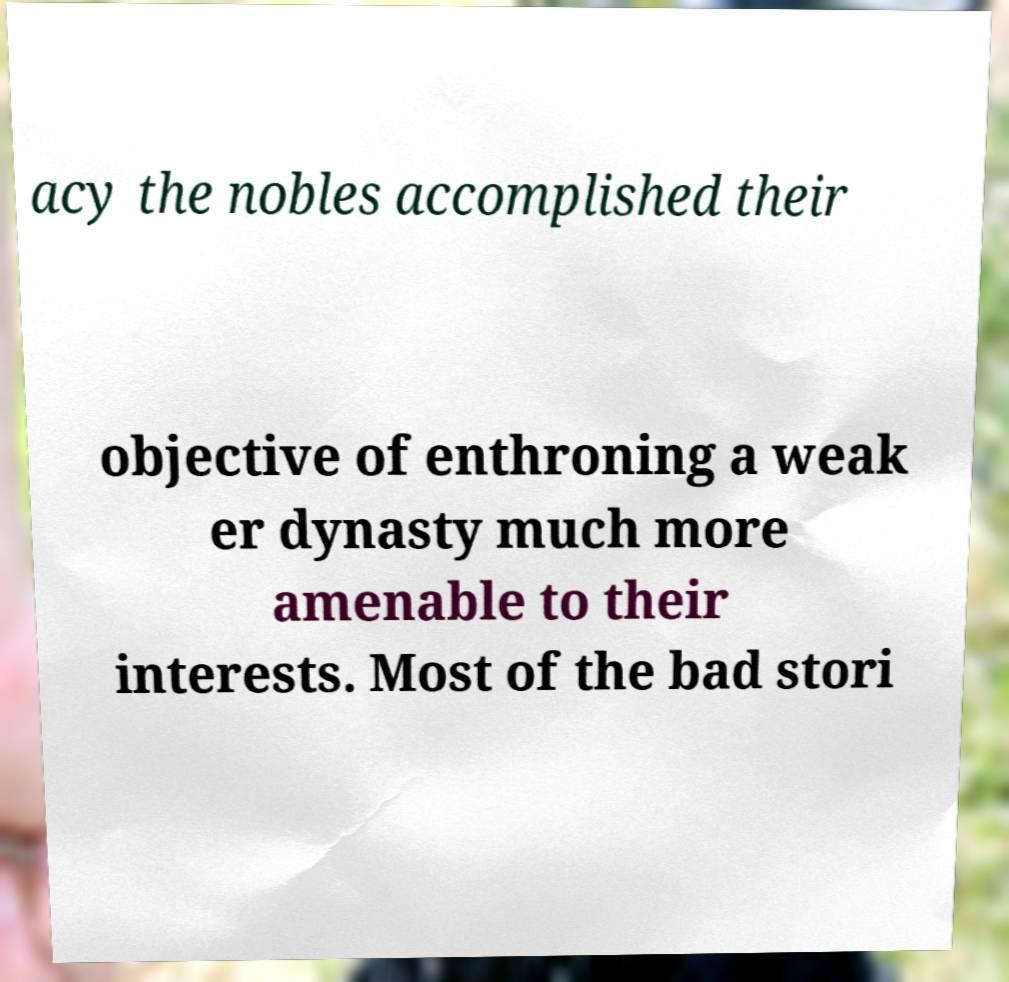I need the written content from this picture converted into text. Can you do that? acy the nobles accomplished their objective of enthroning a weak er dynasty much more amenable to their interests. Most of the bad stori 